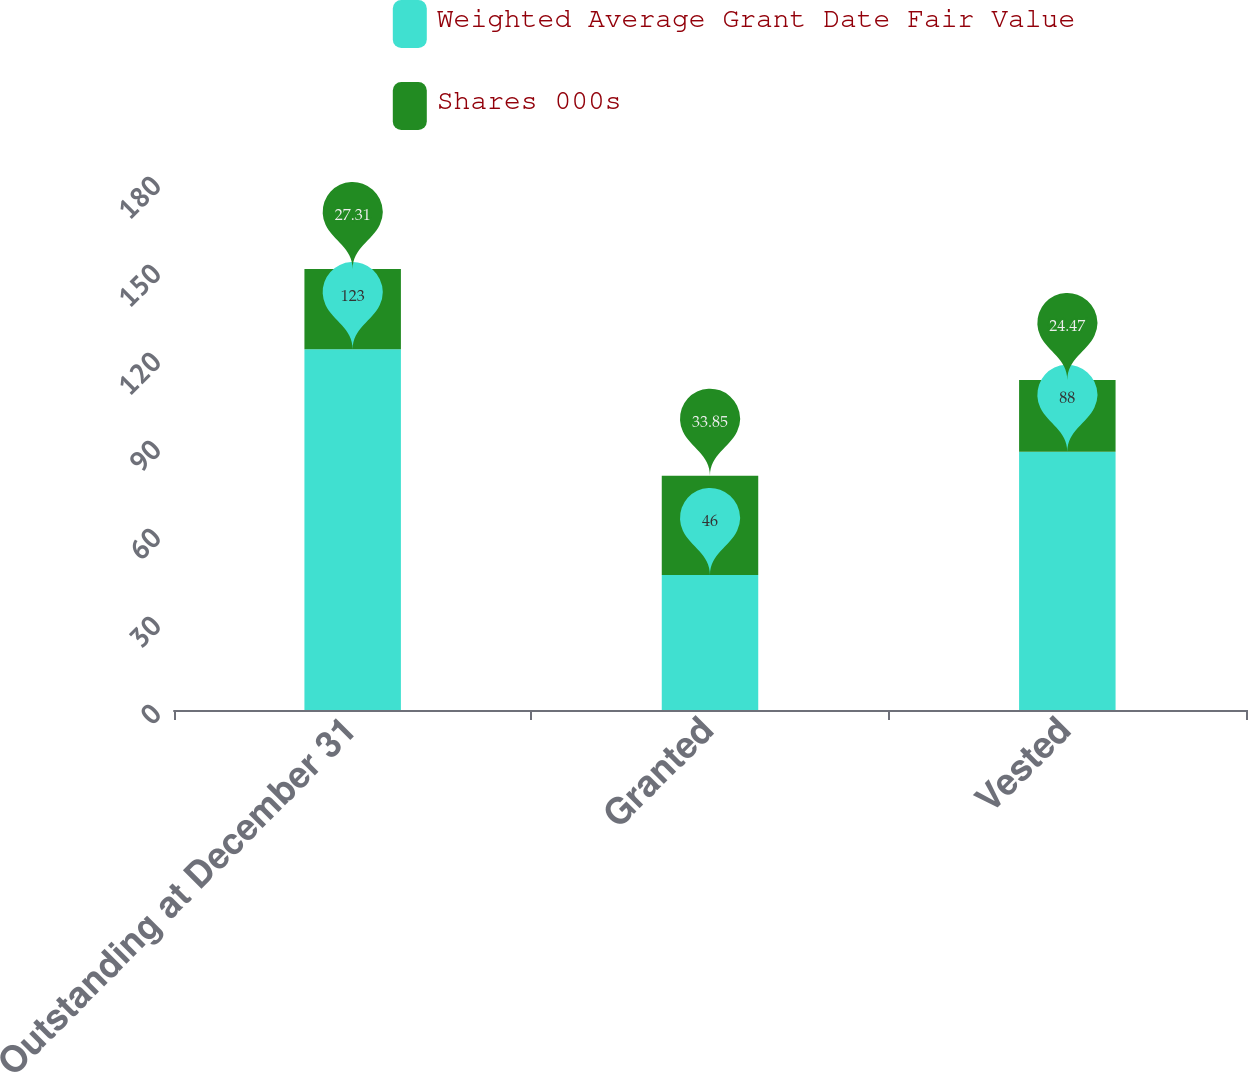<chart> <loc_0><loc_0><loc_500><loc_500><stacked_bar_chart><ecel><fcel>Outstanding at December 31<fcel>Granted<fcel>Vested<nl><fcel>Weighted Average Grant Date Fair Value<fcel>123<fcel>46<fcel>88<nl><fcel>Shares 000s<fcel>27.31<fcel>33.85<fcel>24.47<nl></chart> 